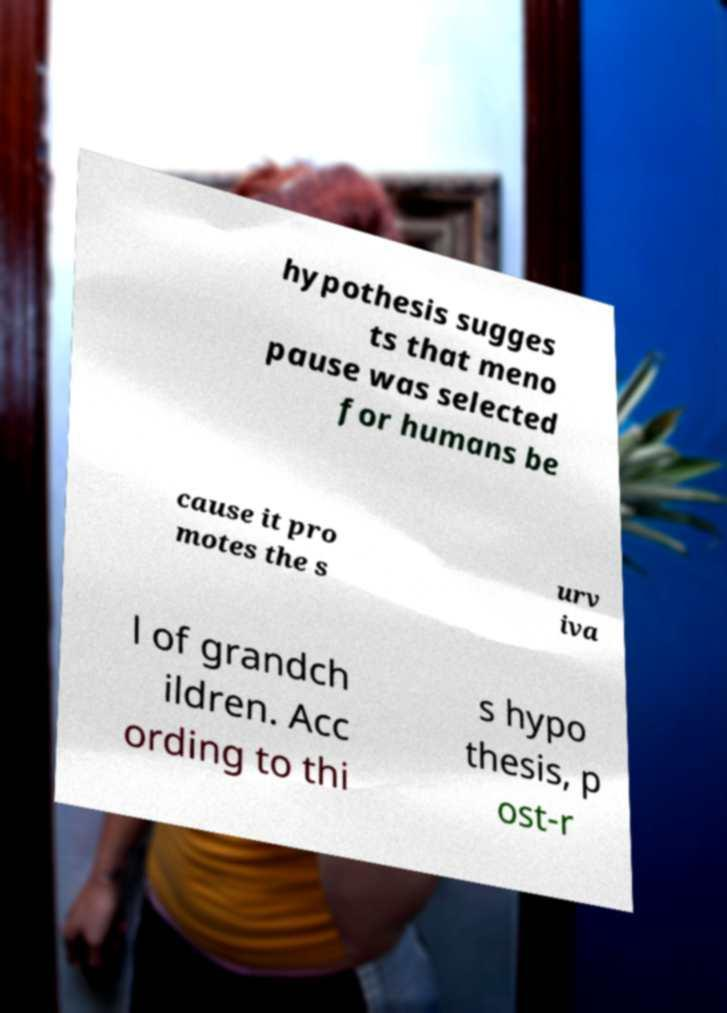Can you accurately transcribe the text from the provided image for me? hypothesis sugges ts that meno pause was selected for humans be cause it pro motes the s urv iva l of grandch ildren. Acc ording to thi s hypo thesis, p ost-r 